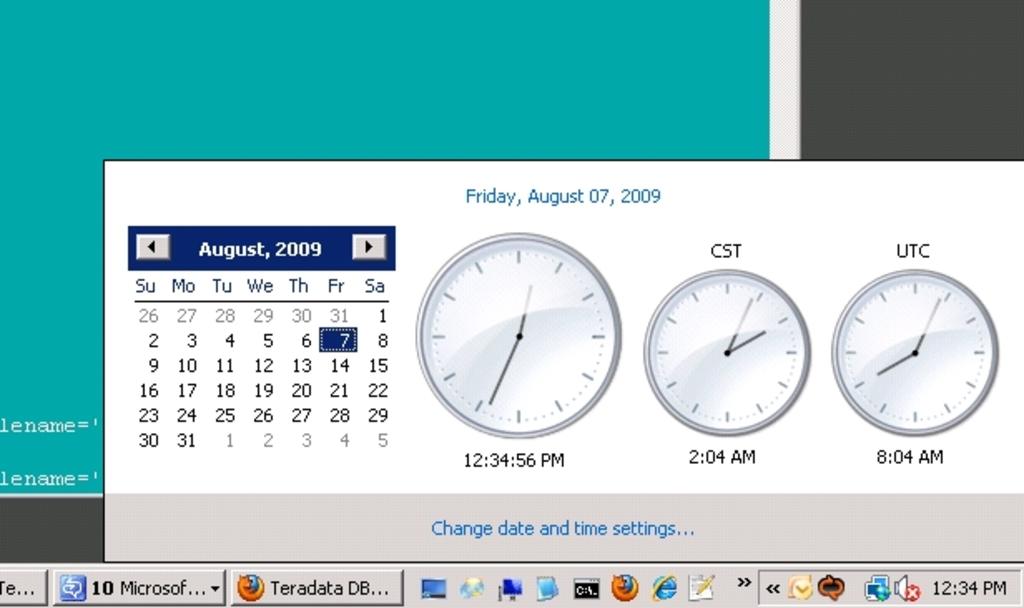What is the date?
Provide a succinct answer. August 7 2009. How many clocks can you see?
Your answer should be very brief. 3. 